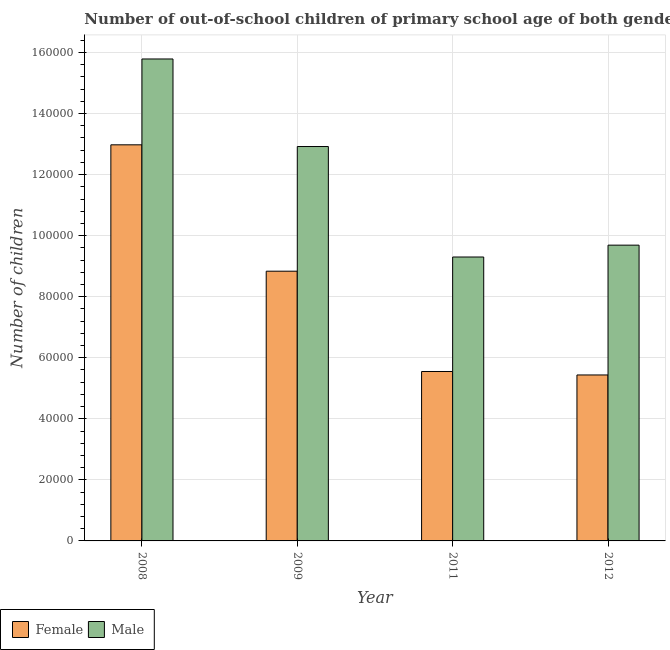How many groups of bars are there?
Offer a terse response. 4. Are the number of bars per tick equal to the number of legend labels?
Your response must be concise. Yes. How many bars are there on the 2nd tick from the left?
Keep it short and to the point. 2. What is the number of female out-of-school students in 2011?
Your answer should be compact. 5.55e+04. Across all years, what is the maximum number of female out-of-school students?
Ensure brevity in your answer.  1.30e+05. Across all years, what is the minimum number of female out-of-school students?
Ensure brevity in your answer.  5.44e+04. What is the total number of female out-of-school students in the graph?
Provide a short and direct response. 3.28e+05. What is the difference between the number of female out-of-school students in 2009 and that in 2011?
Make the answer very short. 3.29e+04. What is the difference between the number of male out-of-school students in 2008 and the number of female out-of-school students in 2009?
Your answer should be very brief. 2.87e+04. What is the average number of male out-of-school students per year?
Offer a very short reply. 1.19e+05. In the year 2009, what is the difference between the number of female out-of-school students and number of male out-of-school students?
Offer a very short reply. 0. What is the ratio of the number of female out-of-school students in 2009 to that in 2011?
Keep it short and to the point. 1.59. Is the difference between the number of female out-of-school students in 2009 and 2012 greater than the difference between the number of male out-of-school students in 2009 and 2012?
Keep it short and to the point. No. What is the difference between the highest and the second highest number of female out-of-school students?
Provide a succinct answer. 4.14e+04. What is the difference between the highest and the lowest number of female out-of-school students?
Keep it short and to the point. 7.54e+04. How many bars are there?
Offer a very short reply. 8. Are all the bars in the graph horizontal?
Your response must be concise. No. Are the values on the major ticks of Y-axis written in scientific E-notation?
Offer a very short reply. No. Does the graph contain grids?
Offer a very short reply. Yes. How many legend labels are there?
Offer a very short reply. 2. What is the title of the graph?
Keep it short and to the point. Number of out-of-school children of primary school age of both genders in Russian Federation. What is the label or title of the X-axis?
Provide a short and direct response. Year. What is the label or title of the Y-axis?
Your answer should be compact. Number of children. What is the Number of children in Female in 2008?
Offer a very short reply. 1.30e+05. What is the Number of children in Male in 2008?
Your answer should be compact. 1.58e+05. What is the Number of children in Female in 2009?
Offer a terse response. 8.84e+04. What is the Number of children in Male in 2009?
Give a very brief answer. 1.29e+05. What is the Number of children in Female in 2011?
Your answer should be compact. 5.55e+04. What is the Number of children of Male in 2011?
Your response must be concise. 9.30e+04. What is the Number of children in Female in 2012?
Your answer should be very brief. 5.44e+04. What is the Number of children of Male in 2012?
Keep it short and to the point. 9.69e+04. Across all years, what is the maximum Number of children in Female?
Make the answer very short. 1.30e+05. Across all years, what is the maximum Number of children of Male?
Your response must be concise. 1.58e+05. Across all years, what is the minimum Number of children of Female?
Give a very brief answer. 5.44e+04. Across all years, what is the minimum Number of children in Male?
Give a very brief answer. 9.30e+04. What is the total Number of children of Female in the graph?
Your answer should be compact. 3.28e+05. What is the total Number of children of Male in the graph?
Make the answer very short. 4.77e+05. What is the difference between the Number of children in Female in 2008 and that in 2009?
Your answer should be compact. 4.14e+04. What is the difference between the Number of children in Male in 2008 and that in 2009?
Give a very brief answer. 2.87e+04. What is the difference between the Number of children in Female in 2008 and that in 2011?
Provide a short and direct response. 7.42e+04. What is the difference between the Number of children in Male in 2008 and that in 2011?
Your response must be concise. 6.49e+04. What is the difference between the Number of children of Female in 2008 and that in 2012?
Ensure brevity in your answer.  7.54e+04. What is the difference between the Number of children in Male in 2008 and that in 2012?
Provide a succinct answer. 6.10e+04. What is the difference between the Number of children in Female in 2009 and that in 2011?
Offer a terse response. 3.29e+04. What is the difference between the Number of children in Male in 2009 and that in 2011?
Your answer should be compact. 3.62e+04. What is the difference between the Number of children of Female in 2009 and that in 2012?
Make the answer very short. 3.40e+04. What is the difference between the Number of children of Male in 2009 and that in 2012?
Give a very brief answer. 3.23e+04. What is the difference between the Number of children of Female in 2011 and that in 2012?
Offer a very short reply. 1138. What is the difference between the Number of children of Male in 2011 and that in 2012?
Offer a terse response. -3887. What is the difference between the Number of children in Female in 2008 and the Number of children in Male in 2009?
Provide a succinct answer. 559. What is the difference between the Number of children of Female in 2008 and the Number of children of Male in 2011?
Your response must be concise. 3.68e+04. What is the difference between the Number of children in Female in 2008 and the Number of children in Male in 2012?
Keep it short and to the point. 3.29e+04. What is the difference between the Number of children of Female in 2009 and the Number of children of Male in 2011?
Provide a succinct answer. -4646. What is the difference between the Number of children in Female in 2009 and the Number of children in Male in 2012?
Keep it short and to the point. -8533. What is the difference between the Number of children in Female in 2011 and the Number of children in Male in 2012?
Your answer should be very brief. -4.14e+04. What is the average Number of children in Female per year?
Provide a short and direct response. 8.20e+04. What is the average Number of children in Male per year?
Make the answer very short. 1.19e+05. In the year 2008, what is the difference between the Number of children of Female and Number of children of Male?
Your response must be concise. -2.81e+04. In the year 2009, what is the difference between the Number of children of Female and Number of children of Male?
Your answer should be compact. -4.08e+04. In the year 2011, what is the difference between the Number of children of Female and Number of children of Male?
Make the answer very short. -3.75e+04. In the year 2012, what is the difference between the Number of children of Female and Number of children of Male?
Offer a very short reply. -4.25e+04. What is the ratio of the Number of children of Female in 2008 to that in 2009?
Provide a succinct answer. 1.47. What is the ratio of the Number of children in Male in 2008 to that in 2009?
Offer a very short reply. 1.22. What is the ratio of the Number of children of Female in 2008 to that in 2011?
Make the answer very short. 2.34. What is the ratio of the Number of children in Male in 2008 to that in 2011?
Ensure brevity in your answer.  1.7. What is the ratio of the Number of children of Female in 2008 to that in 2012?
Provide a succinct answer. 2.39. What is the ratio of the Number of children of Male in 2008 to that in 2012?
Offer a terse response. 1.63. What is the ratio of the Number of children in Female in 2009 to that in 2011?
Provide a short and direct response. 1.59. What is the ratio of the Number of children of Male in 2009 to that in 2011?
Your answer should be very brief. 1.39. What is the ratio of the Number of children in Female in 2009 to that in 2012?
Give a very brief answer. 1.63. What is the ratio of the Number of children in Male in 2009 to that in 2012?
Ensure brevity in your answer.  1.33. What is the ratio of the Number of children of Female in 2011 to that in 2012?
Make the answer very short. 1.02. What is the ratio of the Number of children in Male in 2011 to that in 2012?
Keep it short and to the point. 0.96. What is the difference between the highest and the second highest Number of children of Female?
Your answer should be compact. 4.14e+04. What is the difference between the highest and the second highest Number of children in Male?
Give a very brief answer. 2.87e+04. What is the difference between the highest and the lowest Number of children of Female?
Your answer should be very brief. 7.54e+04. What is the difference between the highest and the lowest Number of children in Male?
Your answer should be compact. 6.49e+04. 